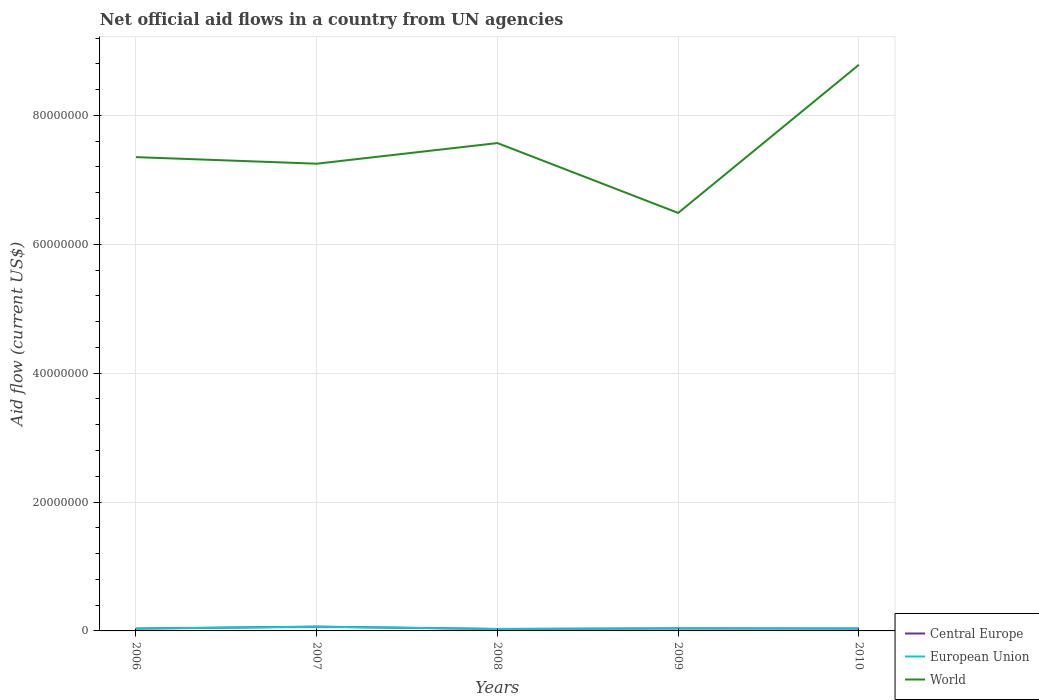How many different coloured lines are there?
Ensure brevity in your answer.  3. Is the number of lines equal to the number of legend labels?
Offer a terse response. Yes. Across all years, what is the maximum net official aid flow in World?
Keep it short and to the point. 6.49e+07. What is the total net official aid flow in European Union in the graph?
Provide a succinct answer. -7.00e+04. What is the difference between the highest and the second highest net official aid flow in World?
Your response must be concise. 2.30e+07. What is the difference between the highest and the lowest net official aid flow in World?
Make the answer very short. 2. How many lines are there?
Your answer should be compact. 3. Are the values on the major ticks of Y-axis written in scientific E-notation?
Provide a succinct answer. No. How many legend labels are there?
Provide a short and direct response. 3. How are the legend labels stacked?
Provide a short and direct response. Vertical. What is the title of the graph?
Keep it short and to the point. Net official aid flows in a country from UN agencies. What is the label or title of the Y-axis?
Offer a terse response. Aid flow (current US$). What is the Aid flow (current US$) of Central Europe in 2006?
Provide a succinct answer. 3.60e+05. What is the Aid flow (current US$) of European Union in 2006?
Keep it short and to the point. 3.60e+05. What is the Aid flow (current US$) of World in 2006?
Provide a short and direct response. 7.35e+07. What is the Aid flow (current US$) of European Union in 2007?
Give a very brief answer. 6.60e+05. What is the Aid flow (current US$) in World in 2007?
Your response must be concise. 7.25e+07. What is the Aid flow (current US$) of Central Europe in 2008?
Make the answer very short. 3.00e+05. What is the Aid flow (current US$) in European Union in 2008?
Offer a very short reply. 3.00e+05. What is the Aid flow (current US$) of World in 2008?
Your response must be concise. 7.57e+07. What is the Aid flow (current US$) in Central Europe in 2009?
Offer a terse response. 3.90e+05. What is the Aid flow (current US$) of European Union in 2009?
Your response must be concise. 3.90e+05. What is the Aid flow (current US$) of World in 2009?
Ensure brevity in your answer.  6.49e+07. What is the Aid flow (current US$) of Central Europe in 2010?
Make the answer very short. 3.70e+05. What is the Aid flow (current US$) of World in 2010?
Keep it short and to the point. 8.79e+07. Across all years, what is the maximum Aid flow (current US$) of European Union?
Your answer should be very brief. 6.60e+05. Across all years, what is the maximum Aid flow (current US$) of World?
Offer a very short reply. 8.79e+07. Across all years, what is the minimum Aid flow (current US$) of World?
Keep it short and to the point. 6.49e+07. What is the total Aid flow (current US$) in Central Europe in the graph?
Your answer should be very brief. 2.08e+06. What is the total Aid flow (current US$) in European Union in the graph?
Your answer should be compact. 2.08e+06. What is the total Aid flow (current US$) of World in the graph?
Keep it short and to the point. 3.74e+08. What is the difference between the Aid flow (current US$) of Central Europe in 2006 and that in 2007?
Provide a succinct answer. -3.00e+05. What is the difference between the Aid flow (current US$) of World in 2006 and that in 2007?
Give a very brief answer. 1.02e+06. What is the difference between the Aid flow (current US$) of Central Europe in 2006 and that in 2008?
Provide a short and direct response. 6.00e+04. What is the difference between the Aid flow (current US$) in European Union in 2006 and that in 2008?
Offer a terse response. 6.00e+04. What is the difference between the Aid flow (current US$) of World in 2006 and that in 2008?
Make the answer very short. -2.18e+06. What is the difference between the Aid flow (current US$) of World in 2006 and that in 2009?
Keep it short and to the point. 8.66e+06. What is the difference between the Aid flow (current US$) of European Union in 2006 and that in 2010?
Make the answer very short. -10000. What is the difference between the Aid flow (current US$) in World in 2006 and that in 2010?
Give a very brief answer. -1.43e+07. What is the difference between the Aid flow (current US$) in Central Europe in 2007 and that in 2008?
Your answer should be compact. 3.60e+05. What is the difference between the Aid flow (current US$) in World in 2007 and that in 2008?
Your answer should be very brief. -3.20e+06. What is the difference between the Aid flow (current US$) of Central Europe in 2007 and that in 2009?
Your answer should be very brief. 2.70e+05. What is the difference between the Aid flow (current US$) in European Union in 2007 and that in 2009?
Offer a terse response. 2.70e+05. What is the difference between the Aid flow (current US$) in World in 2007 and that in 2009?
Your response must be concise. 7.64e+06. What is the difference between the Aid flow (current US$) in Central Europe in 2007 and that in 2010?
Provide a short and direct response. 2.90e+05. What is the difference between the Aid flow (current US$) of World in 2007 and that in 2010?
Provide a succinct answer. -1.54e+07. What is the difference between the Aid flow (current US$) in European Union in 2008 and that in 2009?
Offer a very short reply. -9.00e+04. What is the difference between the Aid flow (current US$) in World in 2008 and that in 2009?
Provide a short and direct response. 1.08e+07. What is the difference between the Aid flow (current US$) in World in 2008 and that in 2010?
Your answer should be compact. -1.22e+07. What is the difference between the Aid flow (current US$) in Central Europe in 2009 and that in 2010?
Offer a very short reply. 2.00e+04. What is the difference between the Aid flow (current US$) of World in 2009 and that in 2010?
Provide a short and direct response. -2.30e+07. What is the difference between the Aid flow (current US$) of Central Europe in 2006 and the Aid flow (current US$) of World in 2007?
Make the answer very short. -7.22e+07. What is the difference between the Aid flow (current US$) of European Union in 2006 and the Aid flow (current US$) of World in 2007?
Provide a succinct answer. -7.22e+07. What is the difference between the Aid flow (current US$) in Central Europe in 2006 and the Aid flow (current US$) in World in 2008?
Offer a terse response. -7.54e+07. What is the difference between the Aid flow (current US$) of European Union in 2006 and the Aid flow (current US$) of World in 2008?
Give a very brief answer. -7.54e+07. What is the difference between the Aid flow (current US$) in Central Europe in 2006 and the Aid flow (current US$) in European Union in 2009?
Give a very brief answer. -3.00e+04. What is the difference between the Aid flow (current US$) of Central Europe in 2006 and the Aid flow (current US$) of World in 2009?
Make the answer very short. -6.45e+07. What is the difference between the Aid flow (current US$) in European Union in 2006 and the Aid flow (current US$) in World in 2009?
Provide a short and direct response. -6.45e+07. What is the difference between the Aid flow (current US$) of Central Europe in 2006 and the Aid flow (current US$) of World in 2010?
Offer a very short reply. -8.75e+07. What is the difference between the Aid flow (current US$) in European Union in 2006 and the Aid flow (current US$) in World in 2010?
Provide a succinct answer. -8.75e+07. What is the difference between the Aid flow (current US$) of Central Europe in 2007 and the Aid flow (current US$) of World in 2008?
Your response must be concise. -7.50e+07. What is the difference between the Aid flow (current US$) of European Union in 2007 and the Aid flow (current US$) of World in 2008?
Keep it short and to the point. -7.50e+07. What is the difference between the Aid flow (current US$) of Central Europe in 2007 and the Aid flow (current US$) of European Union in 2009?
Keep it short and to the point. 2.70e+05. What is the difference between the Aid flow (current US$) of Central Europe in 2007 and the Aid flow (current US$) of World in 2009?
Make the answer very short. -6.42e+07. What is the difference between the Aid flow (current US$) in European Union in 2007 and the Aid flow (current US$) in World in 2009?
Ensure brevity in your answer.  -6.42e+07. What is the difference between the Aid flow (current US$) of Central Europe in 2007 and the Aid flow (current US$) of World in 2010?
Your answer should be compact. -8.72e+07. What is the difference between the Aid flow (current US$) of European Union in 2007 and the Aid flow (current US$) of World in 2010?
Your answer should be very brief. -8.72e+07. What is the difference between the Aid flow (current US$) of Central Europe in 2008 and the Aid flow (current US$) of European Union in 2009?
Keep it short and to the point. -9.00e+04. What is the difference between the Aid flow (current US$) of Central Europe in 2008 and the Aid flow (current US$) of World in 2009?
Ensure brevity in your answer.  -6.46e+07. What is the difference between the Aid flow (current US$) of European Union in 2008 and the Aid flow (current US$) of World in 2009?
Give a very brief answer. -6.46e+07. What is the difference between the Aid flow (current US$) in Central Europe in 2008 and the Aid flow (current US$) in World in 2010?
Make the answer very short. -8.76e+07. What is the difference between the Aid flow (current US$) of European Union in 2008 and the Aid flow (current US$) of World in 2010?
Offer a very short reply. -8.76e+07. What is the difference between the Aid flow (current US$) of Central Europe in 2009 and the Aid flow (current US$) of World in 2010?
Offer a very short reply. -8.75e+07. What is the difference between the Aid flow (current US$) in European Union in 2009 and the Aid flow (current US$) in World in 2010?
Provide a short and direct response. -8.75e+07. What is the average Aid flow (current US$) of Central Europe per year?
Offer a terse response. 4.16e+05. What is the average Aid flow (current US$) of European Union per year?
Provide a succinct answer. 4.16e+05. What is the average Aid flow (current US$) of World per year?
Give a very brief answer. 7.49e+07. In the year 2006, what is the difference between the Aid flow (current US$) of Central Europe and Aid flow (current US$) of European Union?
Offer a terse response. 0. In the year 2006, what is the difference between the Aid flow (current US$) in Central Europe and Aid flow (current US$) in World?
Provide a short and direct response. -7.32e+07. In the year 2006, what is the difference between the Aid flow (current US$) in European Union and Aid flow (current US$) in World?
Keep it short and to the point. -7.32e+07. In the year 2007, what is the difference between the Aid flow (current US$) of Central Europe and Aid flow (current US$) of European Union?
Give a very brief answer. 0. In the year 2007, what is the difference between the Aid flow (current US$) of Central Europe and Aid flow (current US$) of World?
Your response must be concise. -7.18e+07. In the year 2007, what is the difference between the Aid flow (current US$) of European Union and Aid flow (current US$) of World?
Keep it short and to the point. -7.18e+07. In the year 2008, what is the difference between the Aid flow (current US$) in Central Europe and Aid flow (current US$) in European Union?
Make the answer very short. 0. In the year 2008, what is the difference between the Aid flow (current US$) in Central Europe and Aid flow (current US$) in World?
Your answer should be very brief. -7.54e+07. In the year 2008, what is the difference between the Aid flow (current US$) of European Union and Aid flow (current US$) of World?
Give a very brief answer. -7.54e+07. In the year 2009, what is the difference between the Aid flow (current US$) of Central Europe and Aid flow (current US$) of World?
Your answer should be compact. -6.45e+07. In the year 2009, what is the difference between the Aid flow (current US$) in European Union and Aid flow (current US$) in World?
Offer a terse response. -6.45e+07. In the year 2010, what is the difference between the Aid flow (current US$) of Central Europe and Aid flow (current US$) of European Union?
Your answer should be compact. 0. In the year 2010, what is the difference between the Aid flow (current US$) in Central Europe and Aid flow (current US$) in World?
Ensure brevity in your answer.  -8.75e+07. In the year 2010, what is the difference between the Aid flow (current US$) of European Union and Aid flow (current US$) of World?
Provide a short and direct response. -8.75e+07. What is the ratio of the Aid flow (current US$) of Central Europe in 2006 to that in 2007?
Provide a short and direct response. 0.55. What is the ratio of the Aid flow (current US$) of European Union in 2006 to that in 2007?
Offer a very short reply. 0.55. What is the ratio of the Aid flow (current US$) in World in 2006 to that in 2007?
Your response must be concise. 1.01. What is the ratio of the Aid flow (current US$) of Central Europe in 2006 to that in 2008?
Give a very brief answer. 1.2. What is the ratio of the Aid flow (current US$) of World in 2006 to that in 2008?
Give a very brief answer. 0.97. What is the ratio of the Aid flow (current US$) of Central Europe in 2006 to that in 2009?
Your response must be concise. 0.92. What is the ratio of the Aid flow (current US$) in World in 2006 to that in 2009?
Make the answer very short. 1.13. What is the ratio of the Aid flow (current US$) in Central Europe in 2006 to that in 2010?
Offer a terse response. 0.97. What is the ratio of the Aid flow (current US$) of European Union in 2006 to that in 2010?
Keep it short and to the point. 0.97. What is the ratio of the Aid flow (current US$) of World in 2006 to that in 2010?
Provide a succinct answer. 0.84. What is the ratio of the Aid flow (current US$) in World in 2007 to that in 2008?
Provide a succinct answer. 0.96. What is the ratio of the Aid flow (current US$) of Central Europe in 2007 to that in 2009?
Keep it short and to the point. 1.69. What is the ratio of the Aid flow (current US$) in European Union in 2007 to that in 2009?
Offer a very short reply. 1.69. What is the ratio of the Aid flow (current US$) of World in 2007 to that in 2009?
Your answer should be compact. 1.12. What is the ratio of the Aid flow (current US$) in Central Europe in 2007 to that in 2010?
Your response must be concise. 1.78. What is the ratio of the Aid flow (current US$) of European Union in 2007 to that in 2010?
Offer a terse response. 1.78. What is the ratio of the Aid flow (current US$) of World in 2007 to that in 2010?
Your answer should be compact. 0.83. What is the ratio of the Aid flow (current US$) of Central Europe in 2008 to that in 2009?
Offer a terse response. 0.77. What is the ratio of the Aid flow (current US$) of European Union in 2008 to that in 2009?
Provide a succinct answer. 0.77. What is the ratio of the Aid flow (current US$) of World in 2008 to that in 2009?
Give a very brief answer. 1.17. What is the ratio of the Aid flow (current US$) of Central Europe in 2008 to that in 2010?
Give a very brief answer. 0.81. What is the ratio of the Aid flow (current US$) of European Union in 2008 to that in 2010?
Your answer should be very brief. 0.81. What is the ratio of the Aid flow (current US$) of World in 2008 to that in 2010?
Make the answer very short. 0.86. What is the ratio of the Aid flow (current US$) in Central Europe in 2009 to that in 2010?
Keep it short and to the point. 1.05. What is the ratio of the Aid flow (current US$) of European Union in 2009 to that in 2010?
Keep it short and to the point. 1.05. What is the ratio of the Aid flow (current US$) in World in 2009 to that in 2010?
Provide a succinct answer. 0.74. What is the difference between the highest and the second highest Aid flow (current US$) of Central Europe?
Give a very brief answer. 2.70e+05. What is the difference between the highest and the second highest Aid flow (current US$) of European Union?
Your answer should be very brief. 2.70e+05. What is the difference between the highest and the second highest Aid flow (current US$) in World?
Your answer should be very brief. 1.22e+07. What is the difference between the highest and the lowest Aid flow (current US$) in European Union?
Your answer should be compact. 3.60e+05. What is the difference between the highest and the lowest Aid flow (current US$) of World?
Make the answer very short. 2.30e+07. 